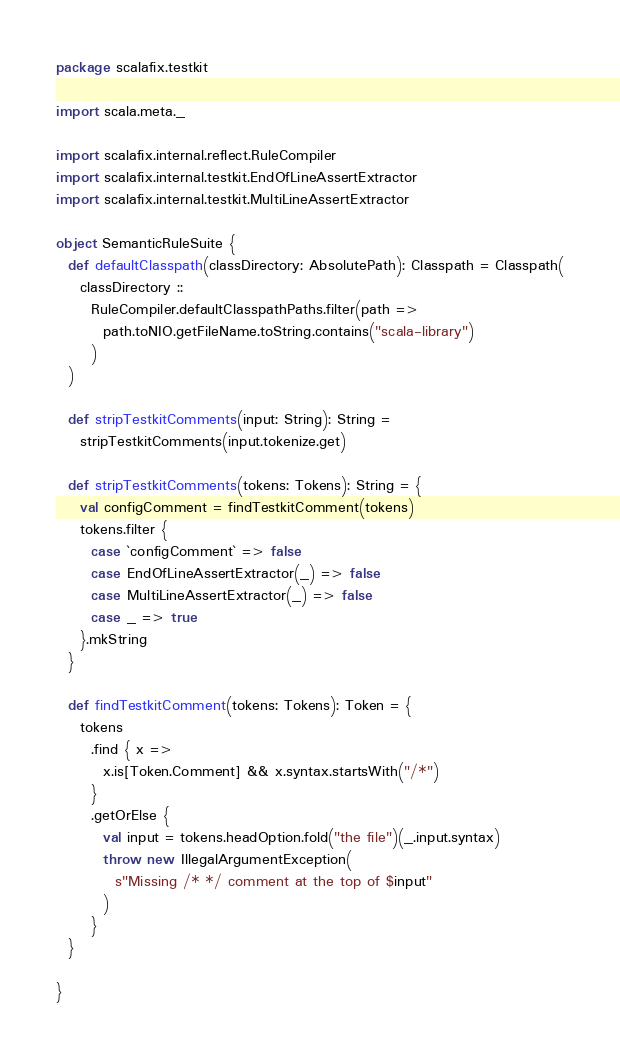<code> <loc_0><loc_0><loc_500><loc_500><_Scala_>package scalafix.testkit

import scala.meta._

import scalafix.internal.reflect.RuleCompiler
import scalafix.internal.testkit.EndOfLineAssertExtractor
import scalafix.internal.testkit.MultiLineAssertExtractor

object SemanticRuleSuite {
  def defaultClasspath(classDirectory: AbsolutePath): Classpath = Classpath(
    classDirectory ::
      RuleCompiler.defaultClasspathPaths.filter(path =>
        path.toNIO.getFileName.toString.contains("scala-library")
      )
  )

  def stripTestkitComments(input: String): String =
    stripTestkitComments(input.tokenize.get)

  def stripTestkitComments(tokens: Tokens): String = {
    val configComment = findTestkitComment(tokens)
    tokens.filter {
      case `configComment` => false
      case EndOfLineAssertExtractor(_) => false
      case MultiLineAssertExtractor(_) => false
      case _ => true
    }.mkString
  }

  def findTestkitComment(tokens: Tokens): Token = {
    tokens
      .find { x =>
        x.is[Token.Comment] && x.syntax.startsWith("/*")
      }
      .getOrElse {
        val input = tokens.headOption.fold("the file")(_.input.syntax)
        throw new IllegalArgumentException(
          s"Missing /* */ comment at the top of $input"
        )
      }
  }

}
</code> 